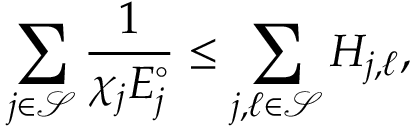Convert formula to latex. <formula><loc_0><loc_0><loc_500><loc_500>\sum _ { j \in \mathcal { S } } \frac { 1 } { \chi _ { j } E _ { j } ^ { \circ } } \leq \sum _ { j , \ell \in \mathcal { S } } H _ { j , \ell } ,</formula> 